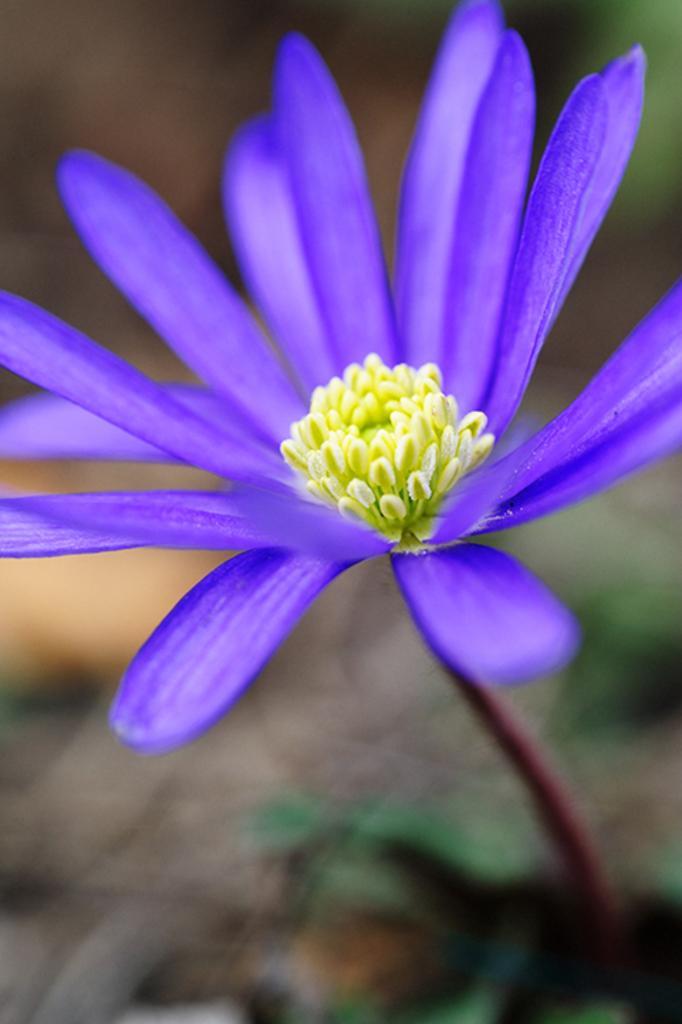How would you summarize this image in a sentence or two? In this picture there is a flower in violet color. The background is blurred. 